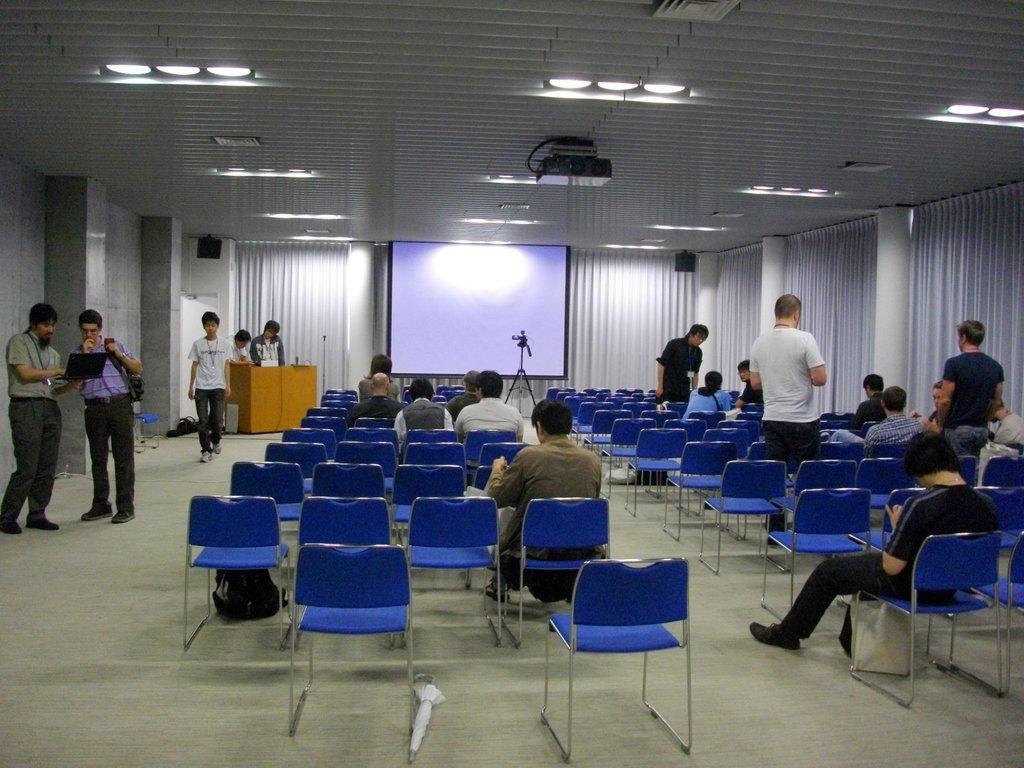Please provide a concise description of this image. This is a closed auditorium. In this room there are group of persons sitting and standing and at the top of the image there is a projector and at the middle of the image there is a projector screen and at the left side of the image there is a wooden block. 